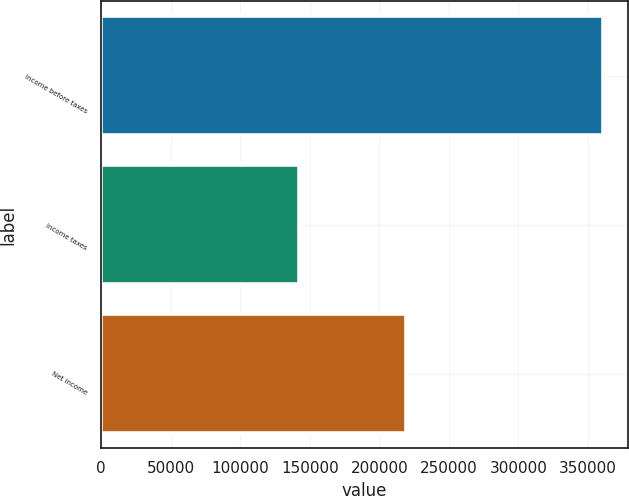Convert chart to OTSL. <chart><loc_0><loc_0><loc_500><loc_500><bar_chart><fcel>Income before taxes<fcel>Income taxes<fcel>Net income<nl><fcel>360860<fcel>141926<fcel>218934<nl></chart> 